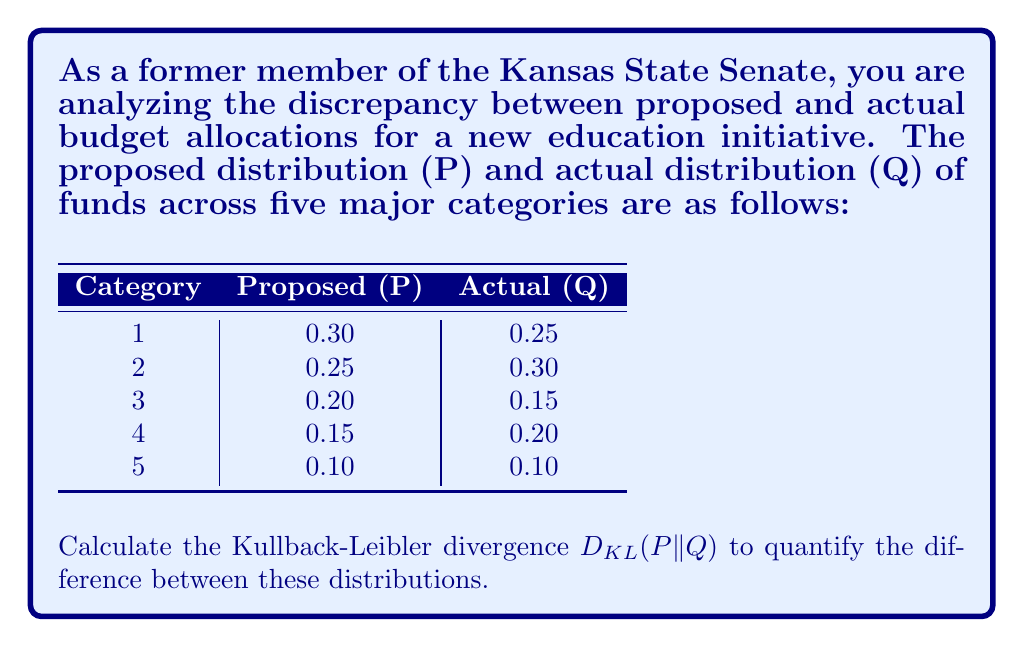Teach me how to tackle this problem. To calculate the Kullback-Leibler divergence between the proposed distribution P and the actual distribution Q, we use the formula:

$$D_{KL}(P||Q) = \sum_{i} P(i) \log\left(\frac{P(i)}{Q(i)}\right)$$

Let's calculate this step-by-step:

1) For category 1:
   $P(1) = 0.30, Q(1) = 0.25$
   $0.30 \log\left(\frac{0.30}{0.25}\right) = 0.30 \log(1.2) = 0.30 \cdot 0.0792 = 0.02376$

2) For category 2:
   $P(2) = 0.25, Q(2) = 0.30$
   $0.25 \log\left(\frac{0.25}{0.30}\right) = 0.25 \log(0.8333) = 0.25 \cdot (-0.0792) = -0.0198$

3) For category 3:
   $P(3) = 0.20, Q(3) = 0.15$
   $0.20 \log\left(\frac{0.20}{0.15}\right) = 0.20 \log(1.3333) = 0.20 \cdot 0.1249 = 0.02498$

4) For category 4:
   $P(4) = 0.15, Q(4) = 0.20$
   $0.15 \log\left(\frac{0.15}{0.20}\right) = 0.15 \log(0.75) = 0.15 \cdot (-0.1249) = -0.01874$

5) For category 5:
   $P(5) = 0.10, Q(5) = 0.10$
   $0.10 \log\left(\frac{0.10}{0.10}\right) = 0.10 \log(1) = 0$

Now, we sum all these values:

$D_{KL}(P||Q) = 0.02376 + (-0.0198) + 0.02498 + (-0.01874) + 0 = 0.0102$

The Kullback-Leibler divergence between the proposed and actual budget allocations is approximately 0.0102 nats.
Answer: $D_{KL}(P||Q) \approx 0.0102$ nats 